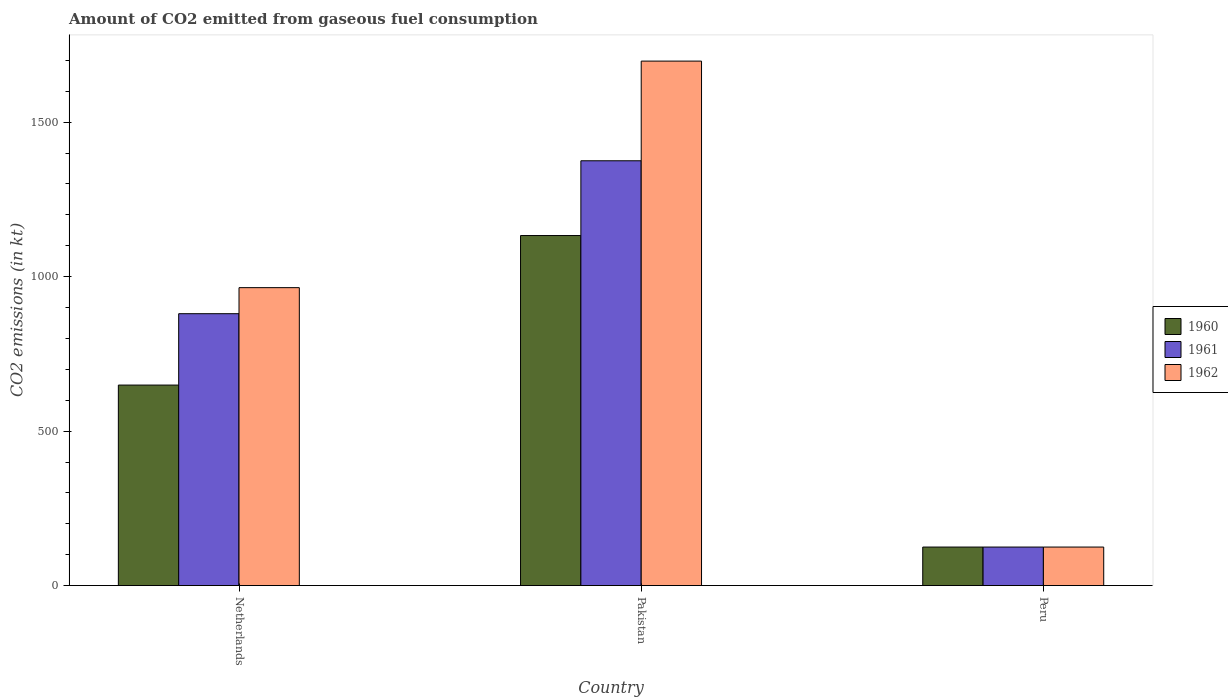How many groups of bars are there?
Keep it short and to the point. 3. How many bars are there on the 1st tick from the left?
Provide a succinct answer. 3. What is the label of the 1st group of bars from the left?
Make the answer very short. Netherlands. In how many cases, is the number of bars for a given country not equal to the number of legend labels?
Your answer should be compact. 0. What is the amount of CO2 emitted in 1961 in Pakistan?
Make the answer very short. 1375.12. Across all countries, what is the maximum amount of CO2 emitted in 1962?
Your answer should be compact. 1697.82. Across all countries, what is the minimum amount of CO2 emitted in 1962?
Keep it short and to the point. 124.68. In which country was the amount of CO2 emitted in 1962 minimum?
Make the answer very short. Peru. What is the total amount of CO2 emitted in 1962 in the graph?
Offer a very short reply. 2786.92. What is the difference between the amount of CO2 emitted in 1962 in Pakistan and that in Peru?
Give a very brief answer. 1573.14. What is the difference between the amount of CO2 emitted in 1960 in Peru and the amount of CO2 emitted in 1961 in Pakistan?
Provide a short and direct response. -1250.45. What is the average amount of CO2 emitted in 1960 per country?
Your response must be concise. 635.61. What is the difference between the amount of CO2 emitted of/in 1960 and amount of CO2 emitted of/in 1961 in Netherlands?
Keep it short and to the point. -231.02. What is the ratio of the amount of CO2 emitted in 1961 in Pakistan to that in Peru?
Provide a succinct answer. 11.03. Is the amount of CO2 emitted in 1962 in Pakistan less than that in Peru?
Offer a very short reply. No. What is the difference between the highest and the second highest amount of CO2 emitted in 1960?
Give a very brief answer. 524.38. What is the difference between the highest and the lowest amount of CO2 emitted in 1962?
Provide a succinct answer. 1573.14. Is the sum of the amount of CO2 emitted in 1961 in Netherlands and Pakistan greater than the maximum amount of CO2 emitted in 1962 across all countries?
Give a very brief answer. Yes. What does the 3rd bar from the left in Netherlands represents?
Make the answer very short. 1962. What does the 2nd bar from the right in Peru represents?
Your answer should be very brief. 1961. Is it the case that in every country, the sum of the amount of CO2 emitted in 1961 and amount of CO2 emitted in 1962 is greater than the amount of CO2 emitted in 1960?
Your answer should be very brief. Yes. How many bars are there?
Offer a terse response. 9. How many countries are there in the graph?
Provide a short and direct response. 3. Are the values on the major ticks of Y-axis written in scientific E-notation?
Give a very brief answer. No. How are the legend labels stacked?
Give a very brief answer. Vertical. What is the title of the graph?
Provide a succinct answer. Amount of CO2 emitted from gaseous fuel consumption. Does "1961" appear as one of the legend labels in the graph?
Your answer should be compact. Yes. What is the label or title of the X-axis?
Keep it short and to the point. Country. What is the label or title of the Y-axis?
Provide a succinct answer. CO2 emissions (in kt). What is the CO2 emissions (in kt) in 1960 in Netherlands?
Your answer should be compact. 649.06. What is the CO2 emissions (in kt) of 1961 in Netherlands?
Give a very brief answer. 880.08. What is the CO2 emissions (in kt) in 1962 in Netherlands?
Keep it short and to the point. 964.42. What is the CO2 emissions (in kt) in 1960 in Pakistan?
Offer a very short reply. 1133.1. What is the CO2 emissions (in kt) in 1961 in Pakistan?
Give a very brief answer. 1375.12. What is the CO2 emissions (in kt) in 1962 in Pakistan?
Offer a very short reply. 1697.82. What is the CO2 emissions (in kt) of 1960 in Peru?
Provide a succinct answer. 124.68. What is the CO2 emissions (in kt) in 1961 in Peru?
Offer a terse response. 124.68. What is the CO2 emissions (in kt) of 1962 in Peru?
Your answer should be very brief. 124.68. Across all countries, what is the maximum CO2 emissions (in kt) in 1960?
Your answer should be compact. 1133.1. Across all countries, what is the maximum CO2 emissions (in kt) in 1961?
Give a very brief answer. 1375.12. Across all countries, what is the maximum CO2 emissions (in kt) in 1962?
Your answer should be very brief. 1697.82. Across all countries, what is the minimum CO2 emissions (in kt) of 1960?
Ensure brevity in your answer.  124.68. Across all countries, what is the minimum CO2 emissions (in kt) of 1961?
Your answer should be compact. 124.68. Across all countries, what is the minimum CO2 emissions (in kt) of 1962?
Give a very brief answer. 124.68. What is the total CO2 emissions (in kt) of 1960 in the graph?
Provide a succinct answer. 1906.84. What is the total CO2 emissions (in kt) of 1961 in the graph?
Provide a short and direct response. 2379.88. What is the total CO2 emissions (in kt) in 1962 in the graph?
Ensure brevity in your answer.  2786.92. What is the difference between the CO2 emissions (in kt) of 1960 in Netherlands and that in Pakistan?
Keep it short and to the point. -484.04. What is the difference between the CO2 emissions (in kt) of 1961 in Netherlands and that in Pakistan?
Provide a short and direct response. -495.05. What is the difference between the CO2 emissions (in kt) in 1962 in Netherlands and that in Pakistan?
Your answer should be very brief. -733.4. What is the difference between the CO2 emissions (in kt) in 1960 in Netherlands and that in Peru?
Give a very brief answer. 524.38. What is the difference between the CO2 emissions (in kt) of 1961 in Netherlands and that in Peru?
Offer a terse response. 755.4. What is the difference between the CO2 emissions (in kt) of 1962 in Netherlands and that in Peru?
Your answer should be very brief. 839.74. What is the difference between the CO2 emissions (in kt) of 1960 in Pakistan and that in Peru?
Make the answer very short. 1008.42. What is the difference between the CO2 emissions (in kt) of 1961 in Pakistan and that in Peru?
Make the answer very short. 1250.45. What is the difference between the CO2 emissions (in kt) in 1962 in Pakistan and that in Peru?
Provide a succinct answer. 1573.14. What is the difference between the CO2 emissions (in kt) in 1960 in Netherlands and the CO2 emissions (in kt) in 1961 in Pakistan?
Offer a very short reply. -726.07. What is the difference between the CO2 emissions (in kt) of 1960 in Netherlands and the CO2 emissions (in kt) of 1962 in Pakistan?
Make the answer very short. -1048.76. What is the difference between the CO2 emissions (in kt) in 1961 in Netherlands and the CO2 emissions (in kt) in 1962 in Pakistan?
Your answer should be compact. -817.74. What is the difference between the CO2 emissions (in kt) in 1960 in Netherlands and the CO2 emissions (in kt) in 1961 in Peru?
Your answer should be compact. 524.38. What is the difference between the CO2 emissions (in kt) in 1960 in Netherlands and the CO2 emissions (in kt) in 1962 in Peru?
Offer a very short reply. 524.38. What is the difference between the CO2 emissions (in kt) in 1961 in Netherlands and the CO2 emissions (in kt) in 1962 in Peru?
Ensure brevity in your answer.  755.4. What is the difference between the CO2 emissions (in kt) in 1960 in Pakistan and the CO2 emissions (in kt) in 1961 in Peru?
Give a very brief answer. 1008.42. What is the difference between the CO2 emissions (in kt) of 1960 in Pakistan and the CO2 emissions (in kt) of 1962 in Peru?
Ensure brevity in your answer.  1008.42. What is the difference between the CO2 emissions (in kt) in 1961 in Pakistan and the CO2 emissions (in kt) in 1962 in Peru?
Your answer should be very brief. 1250.45. What is the average CO2 emissions (in kt) in 1960 per country?
Make the answer very short. 635.61. What is the average CO2 emissions (in kt) in 1961 per country?
Your answer should be very brief. 793.29. What is the average CO2 emissions (in kt) in 1962 per country?
Give a very brief answer. 928.97. What is the difference between the CO2 emissions (in kt) in 1960 and CO2 emissions (in kt) in 1961 in Netherlands?
Offer a very short reply. -231.02. What is the difference between the CO2 emissions (in kt) in 1960 and CO2 emissions (in kt) in 1962 in Netherlands?
Offer a very short reply. -315.36. What is the difference between the CO2 emissions (in kt) of 1961 and CO2 emissions (in kt) of 1962 in Netherlands?
Provide a succinct answer. -84.34. What is the difference between the CO2 emissions (in kt) in 1960 and CO2 emissions (in kt) in 1961 in Pakistan?
Your response must be concise. -242.02. What is the difference between the CO2 emissions (in kt) in 1960 and CO2 emissions (in kt) in 1962 in Pakistan?
Ensure brevity in your answer.  -564.72. What is the difference between the CO2 emissions (in kt) in 1961 and CO2 emissions (in kt) in 1962 in Pakistan?
Offer a terse response. -322.7. What is the difference between the CO2 emissions (in kt) in 1960 and CO2 emissions (in kt) in 1961 in Peru?
Give a very brief answer. 0. What is the ratio of the CO2 emissions (in kt) of 1960 in Netherlands to that in Pakistan?
Provide a short and direct response. 0.57. What is the ratio of the CO2 emissions (in kt) of 1961 in Netherlands to that in Pakistan?
Offer a very short reply. 0.64. What is the ratio of the CO2 emissions (in kt) in 1962 in Netherlands to that in Pakistan?
Offer a terse response. 0.57. What is the ratio of the CO2 emissions (in kt) in 1960 in Netherlands to that in Peru?
Your answer should be very brief. 5.21. What is the ratio of the CO2 emissions (in kt) of 1961 in Netherlands to that in Peru?
Give a very brief answer. 7.06. What is the ratio of the CO2 emissions (in kt) in 1962 in Netherlands to that in Peru?
Make the answer very short. 7.74. What is the ratio of the CO2 emissions (in kt) of 1960 in Pakistan to that in Peru?
Make the answer very short. 9.09. What is the ratio of the CO2 emissions (in kt) in 1961 in Pakistan to that in Peru?
Give a very brief answer. 11.03. What is the ratio of the CO2 emissions (in kt) in 1962 in Pakistan to that in Peru?
Make the answer very short. 13.62. What is the difference between the highest and the second highest CO2 emissions (in kt) of 1960?
Provide a succinct answer. 484.04. What is the difference between the highest and the second highest CO2 emissions (in kt) in 1961?
Provide a short and direct response. 495.05. What is the difference between the highest and the second highest CO2 emissions (in kt) in 1962?
Offer a terse response. 733.4. What is the difference between the highest and the lowest CO2 emissions (in kt) of 1960?
Offer a terse response. 1008.42. What is the difference between the highest and the lowest CO2 emissions (in kt) in 1961?
Your answer should be very brief. 1250.45. What is the difference between the highest and the lowest CO2 emissions (in kt) of 1962?
Make the answer very short. 1573.14. 